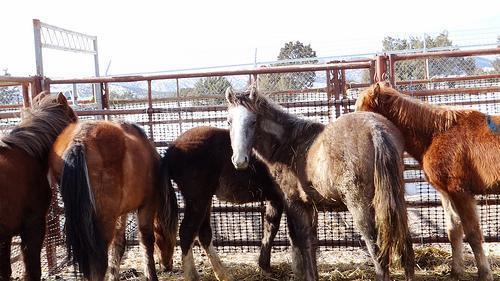How many horses are there?
Give a very brief answer. 5. 